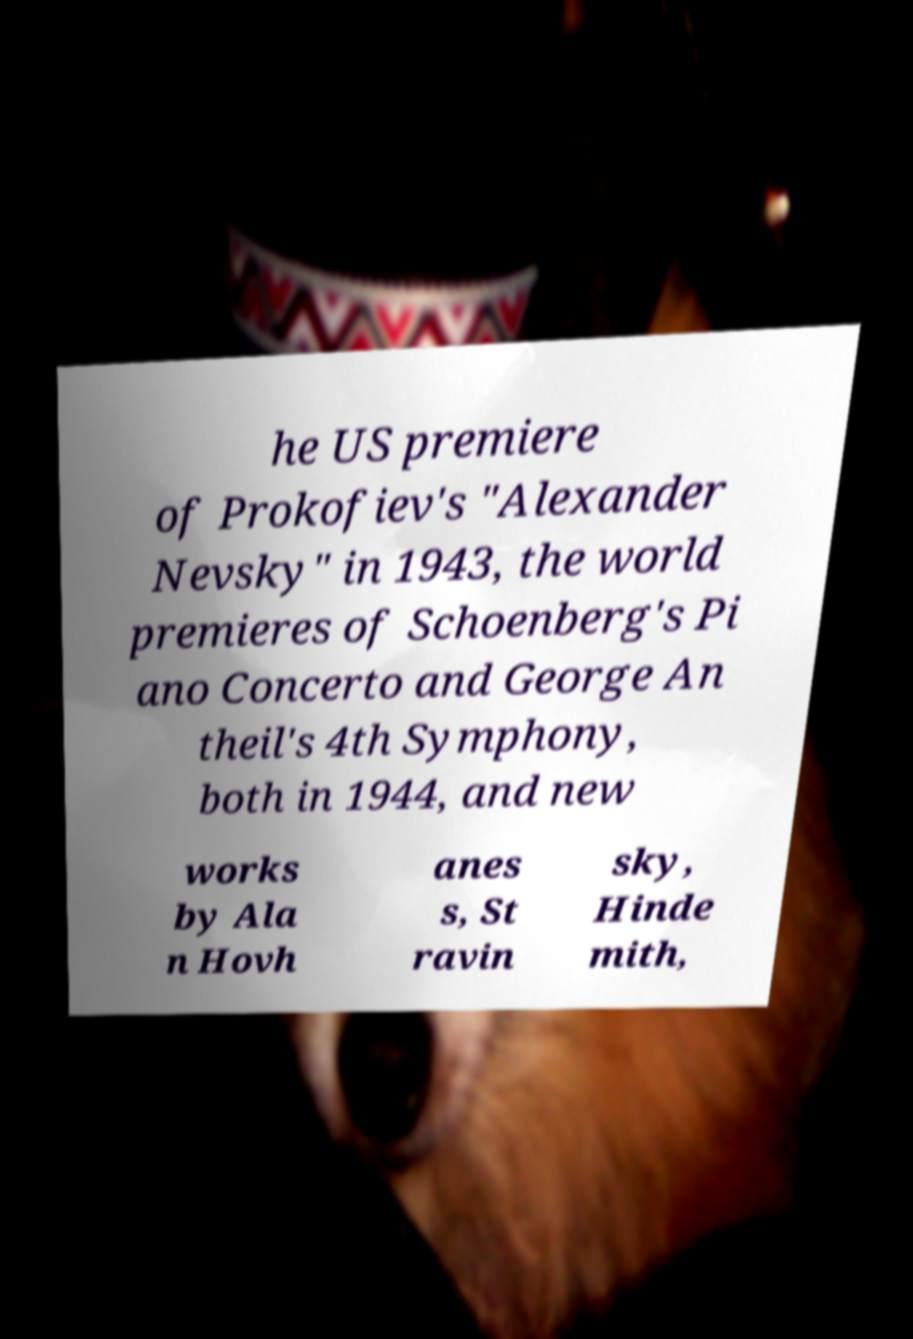Please read and relay the text visible in this image. What does it say? he US premiere of Prokofiev's "Alexander Nevsky" in 1943, the world premieres of Schoenberg's Pi ano Concerto and George An theil's 4th Symphony, both in 1944, and new works by Ala n Hovh anes s, St ravin sky, Hinde mith, 